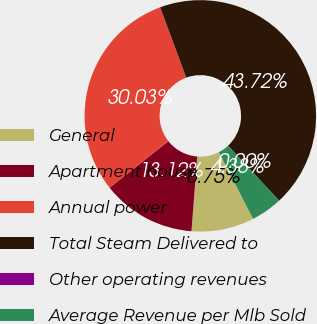Convert chart. <chart><loc_0><loc_0><loc_500><loc_500><pie_chart><fcel>General<fcel>Apartment house<fcel>Annual power<fcel>Total Steam Delivered to<fcel>Other operating revenues<fcel>Average Revenue per Mlb Sold<nl><fcel>8.75%<fcel>13.12%<fcel>30.03%<fcel>43.72%<fcel>0.0%<fcel>4.38%<nl></chart> 